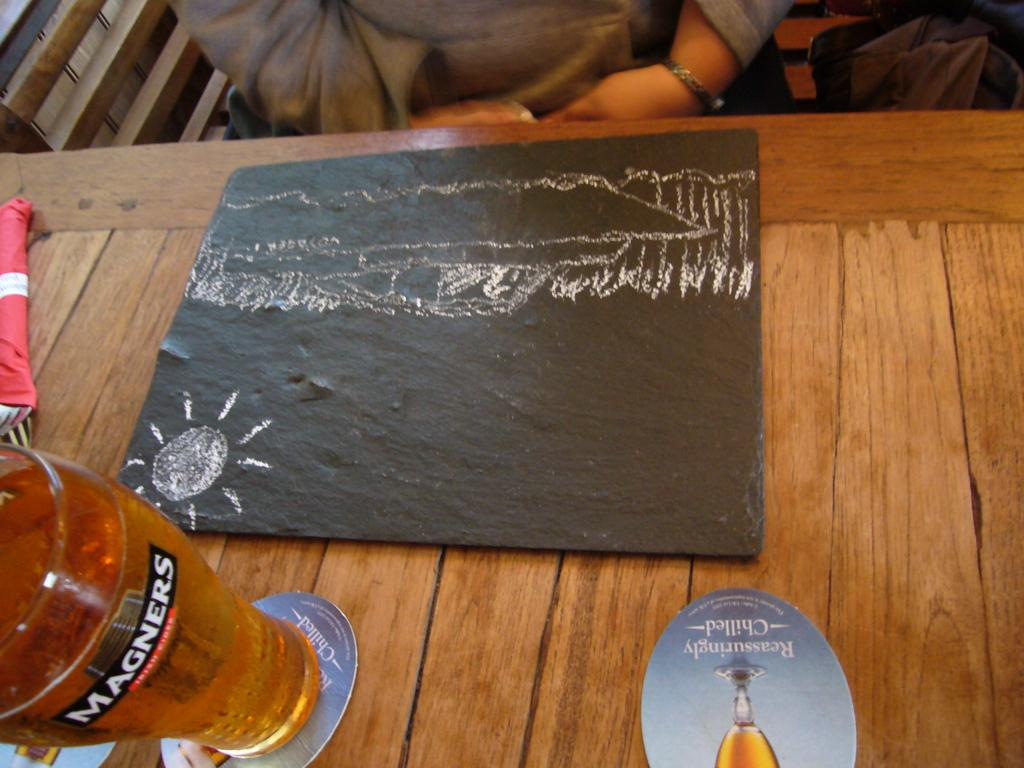Provide a one-sentence caption for the provided image. A Chalk Drawing sits next to a Magners glass of beer. 